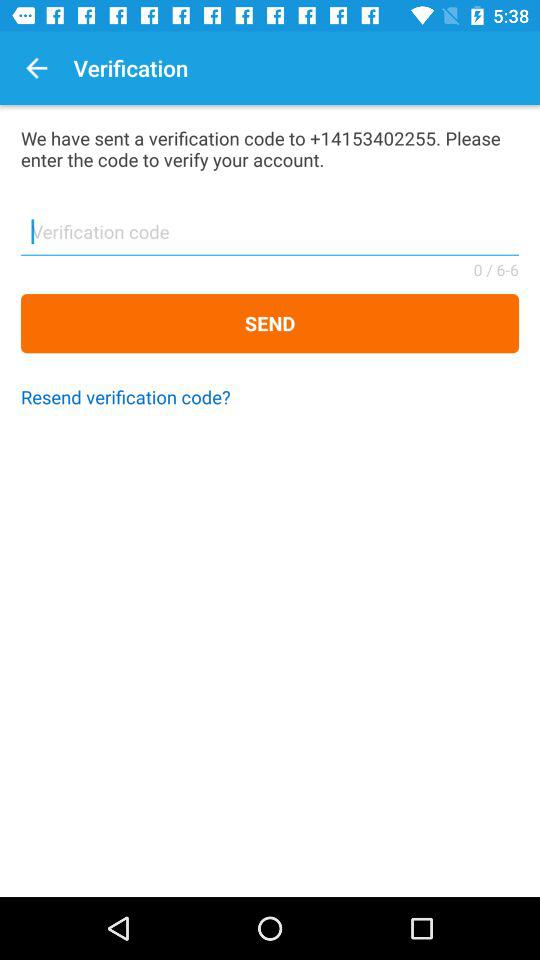How many digits are there in the verification code? There are 6 digits in the verification code. 